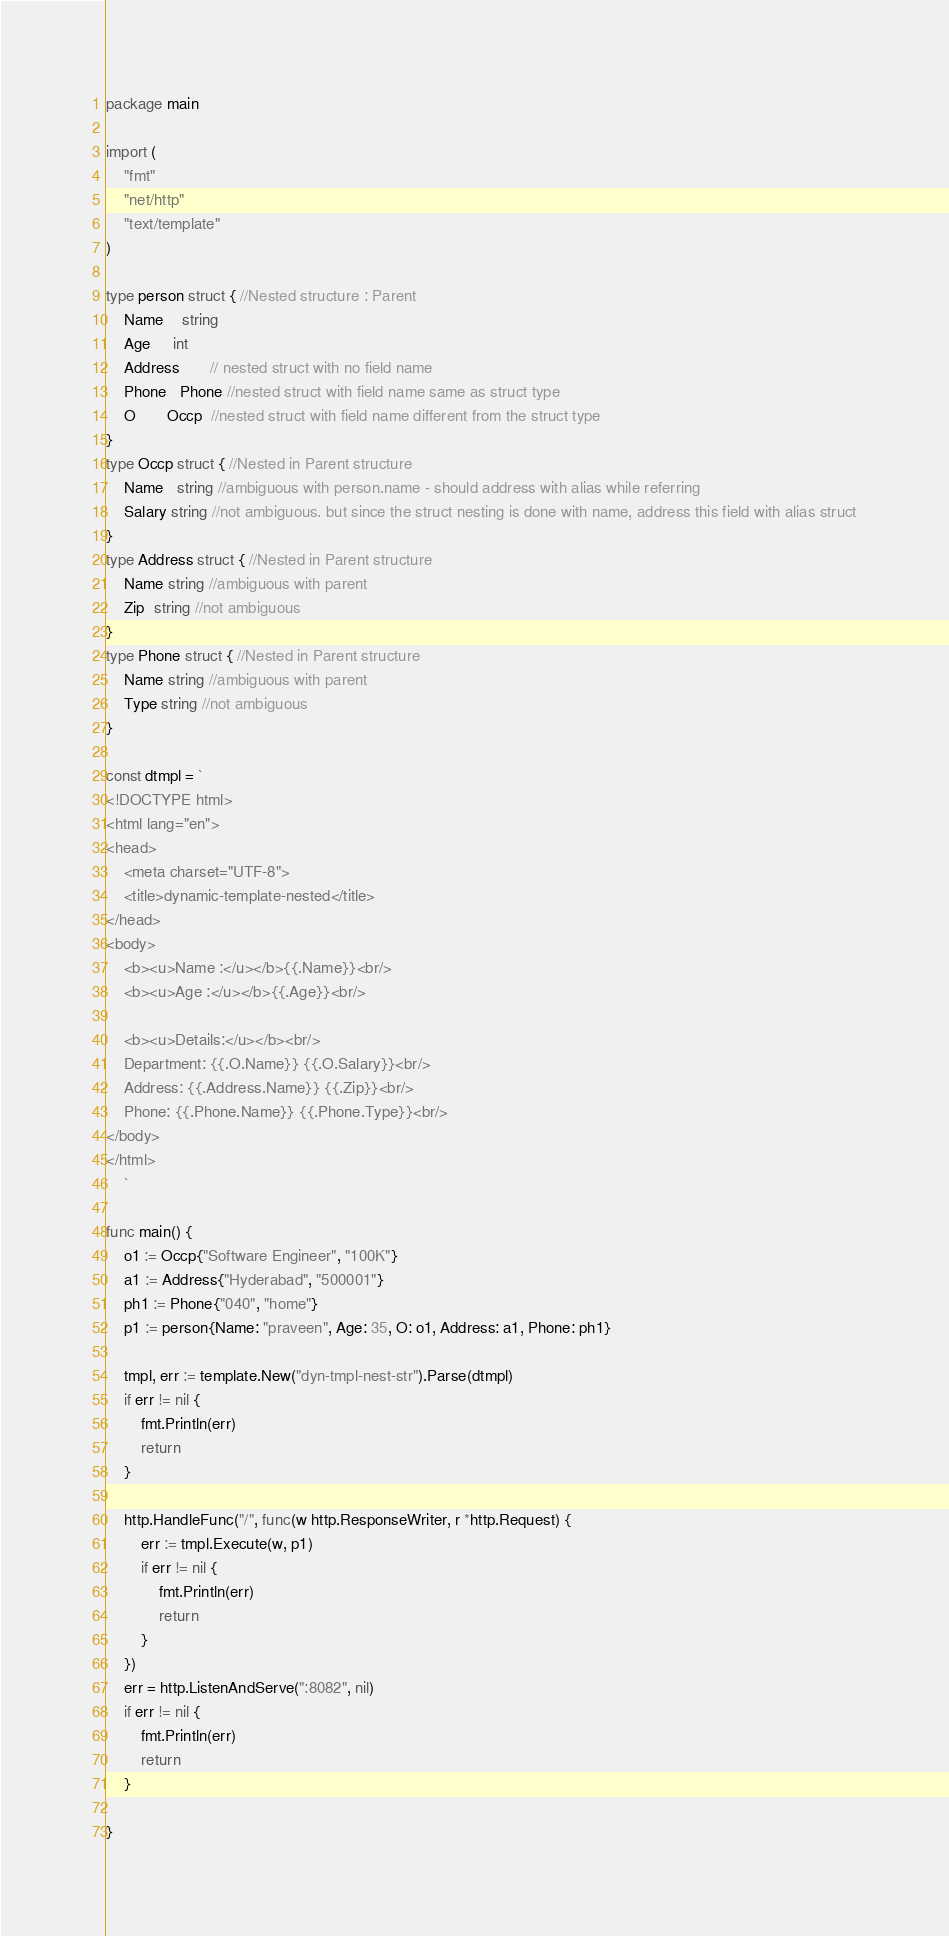<code> <loc_0><loc_0><loc_500><loc_500><_Go_>package main

import (
	"fmt"
	"net/http"
	"text/template"
)

type person struct { //Nested structure : Parent
	Name    string
	Age     int
	Address       // nested struct with no field name
	Phone   Phone //nested struct with field name same as struct type
	O       Occp  //nested struct with field name different from the struct type
}
type Occp struct { //Nested in Parent structure
	Name   string //ambiguous with person.name - should address with alias while referring
	Salary string //not ambiguous. but since the struct nesting is done with name, address this field with alias struct
}
type Address struct { //Nested in Parent structure
	Name string //ambiguous with parent
	Zip  string //not ambiguous
}
type Phone struct { //Nested in Parent structure
	Name string //ambiguous with parent
	Type string //not ambiguous
}

const dtmpl = `
<!DOCTYPE html>
<html lang="en">
<head>
    <meta charset="UTF-8">
    <title>dynamic-template-nested</title>
</head>
<body>
    <b><u>Name :</u></b>{{.Name}}<br/>
    <b><u>Age :</u></b>{{.Age}}<br/>

    <b><u>Details:</u></b><br/>
    Department: {{.O.Name}} {{.O.Salary}}<br/>
	Address: {{.Address.Name}} {{.Zip}}<br/>
	Phone: {{.Phone.Name}} {{.Phone.Type}}<br/>
</body>
</html>
	`

func main() {
	o1 := Occp{"Software Engineer", "100K"}
	a1 := Address{"Hyderabad", "500001"}
	ph1 := Phone{"040", "home"}
	p1 := person{Name: "praveen", Age: 35, O: o1, Address: a1, Phone: ph1}

	tmpl, err := template.New("dyn-tmpl-nest-str").Parse(dtmpl)
	if err != nil {
		fmt.Println(err)
		return
	}

	http.HandleFunc("/", func(w http.ResponseWriter, r *http.Request) {
		err := tmpl.Execute(w, p1)
		if err != nil {
			fmt.Println(err)
			return
		}
	})
	err = http.ListenAndServe(":8082", nil)
	if err != nil {
		fmt.Println(err)
		return
	}

}
</code> 